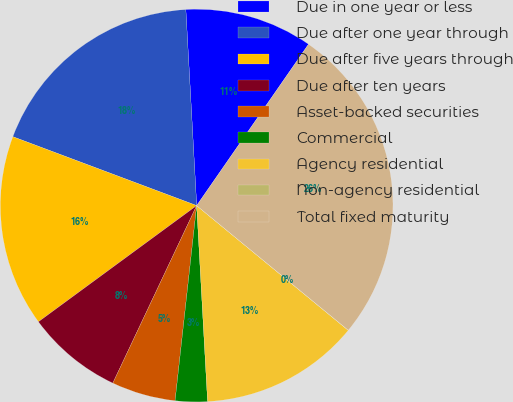Convert chart. <chart><loc_0><loc_0><loc_500><loc_500><pie_chart><fcel>Due in one year or less<fcel>Due after one year through<fcel>Due after five years through<fcel>Due after ten years<fcel>Asset-backed securities<fcel>Commercial<fcel>Agency residential<fcel>Non-agency residential<fcel>Total fixed maturity<nl><fcel>10.53%<fcel>18.42%<fcel>15.79%<fcel>7.9%<fcel>5.27%<fcel>2.64%<fcel>13.16%<fcel>0.01%<fcel>26.31%<nl></chart> 